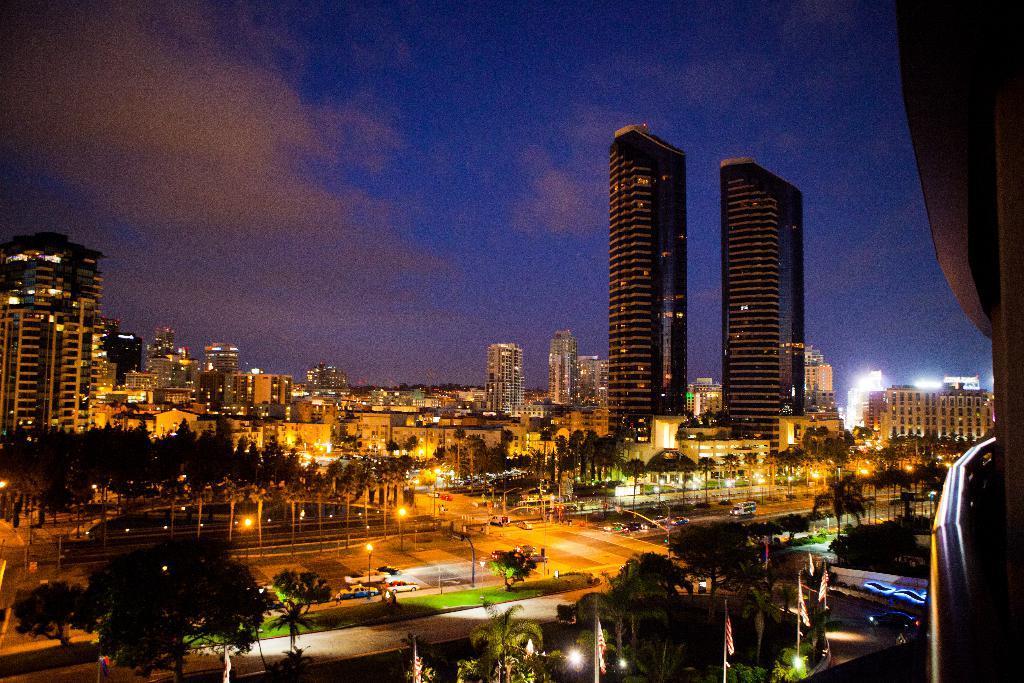In one or two sentences, can you explain what this image depicts? In the picture I can see buildings, trees, vehicles on roads, street lights and other objects. In the background I can see the sky. 